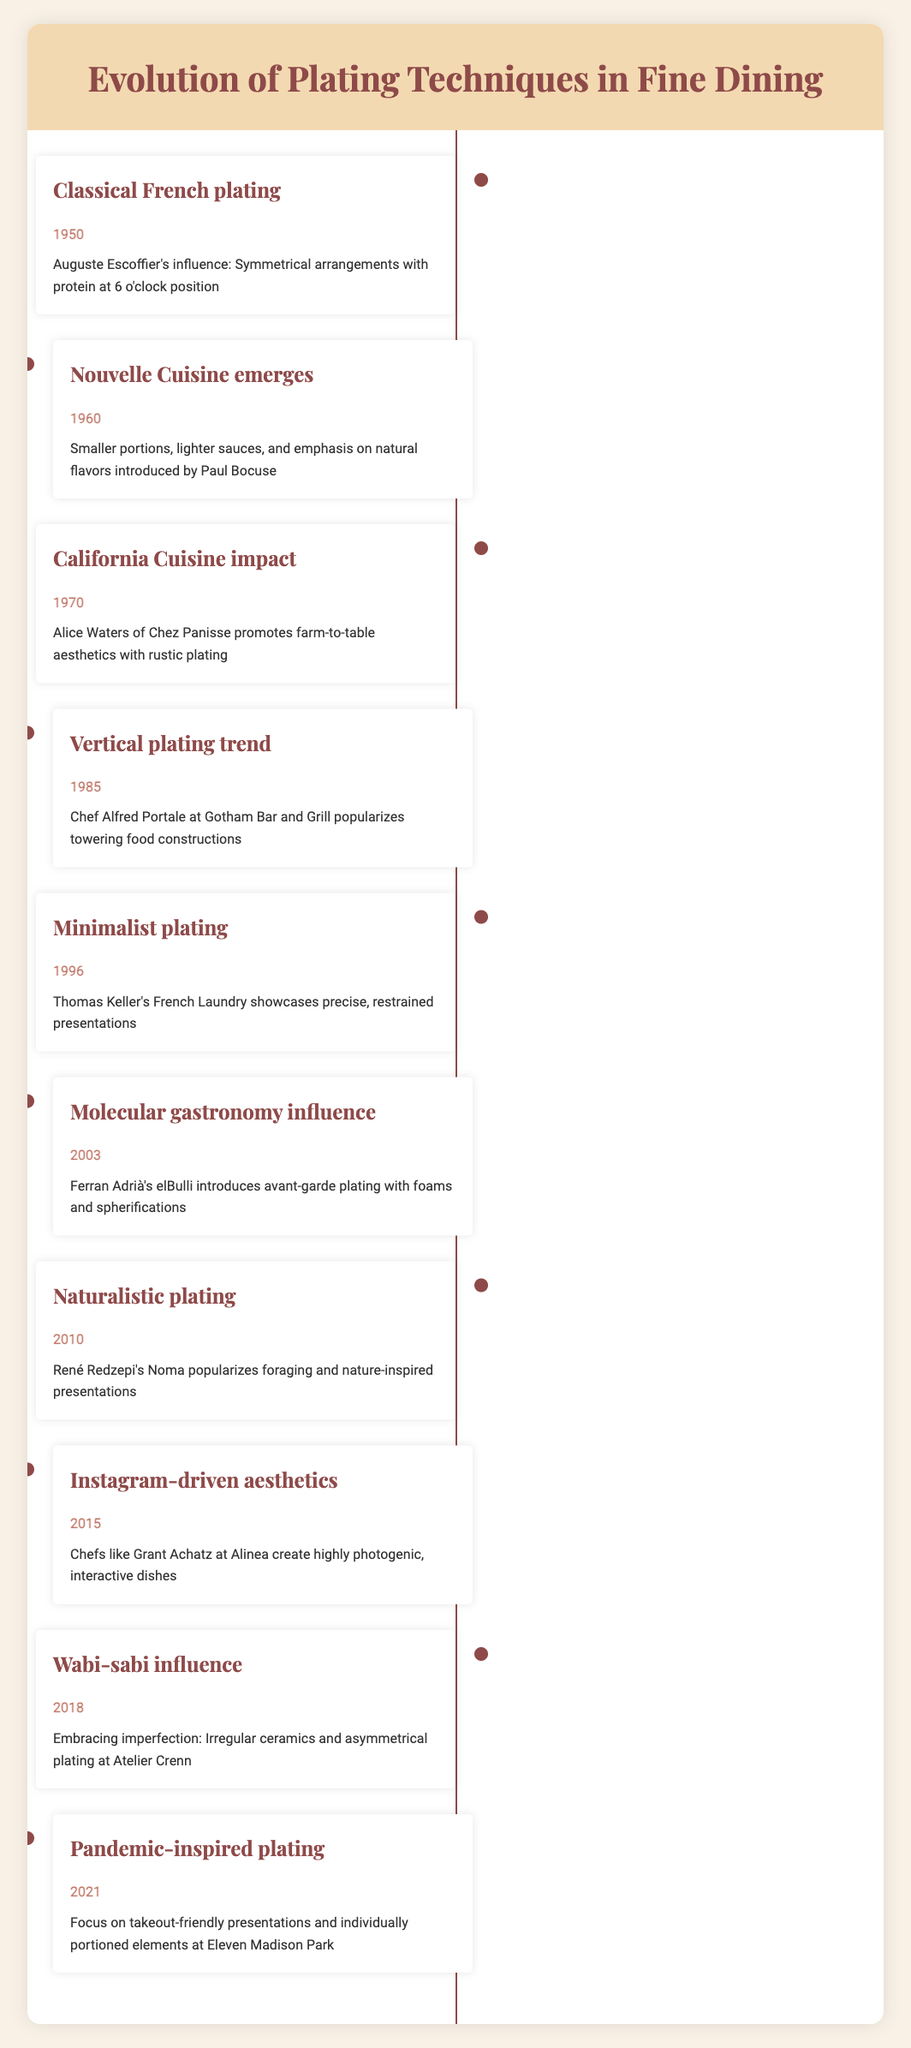What event marked the introduction of minimalist plating? The table shows that minimalist plating was introduced in 1996 by Thomas Keller's French Laundry, which is explicitly stated in the event and description.
Answer: Minimalist plating in 1996 Which year did the trend of Instagram-driven aesthetics emerge in plating? According to the table, Instagram-driven aesthetics emerged in 2015 as described under the corresponding event.
Answer: 2015 Was the California Cuisine impact associated with larger portions in plating? The data indicates that the California Cuisine impact in 1970, described by Alice Waters, promoted smaller, rustic presentations rather than larger portions.
Answer: No What is the chronological order of the events starting from the Classical French plating to Pandemic-inspired plating? By referencing the years listed in the table, we can see that the order is as follows: Classical French plating (1950), Nouvelle Cuisine (1960), California Cuisine (1970), Vertical plating (1985), Minimalist plating (1996), Molecular gastronomy (2003), Naturalistic plating (2010), Instagram-driven aesthetics (2015), Wabi-sabi influence (2018), and Pandemic-inspired plating (2021).
Answer: Classical French plating, Nouvelle Cuisine, California Cuisine, Vertical plating, Minimalist plating, Molecular gastronomy, Naturalistic plating, Instagram-driven aesthetics, Wabi-sabi influence, Pandemic-inspired plating Which plating event occurred closest to the start of the 21st century? By looking at the timeline provided, the event that occurred closest to the start of the 21st century is the minimalist plating trend in 1996, which is the last event before 2000.
Answer: Minimalist plating in 1996 How many years passed between the introduction of vertical plating and the emergence of molecular gastronomy? The vertical plating trend was introduced in 1985 and molecular gastronomy influence was observed in 2003. Therefore, the difference is 2003 - 1985 = 18 years.
Answer: 18 years 